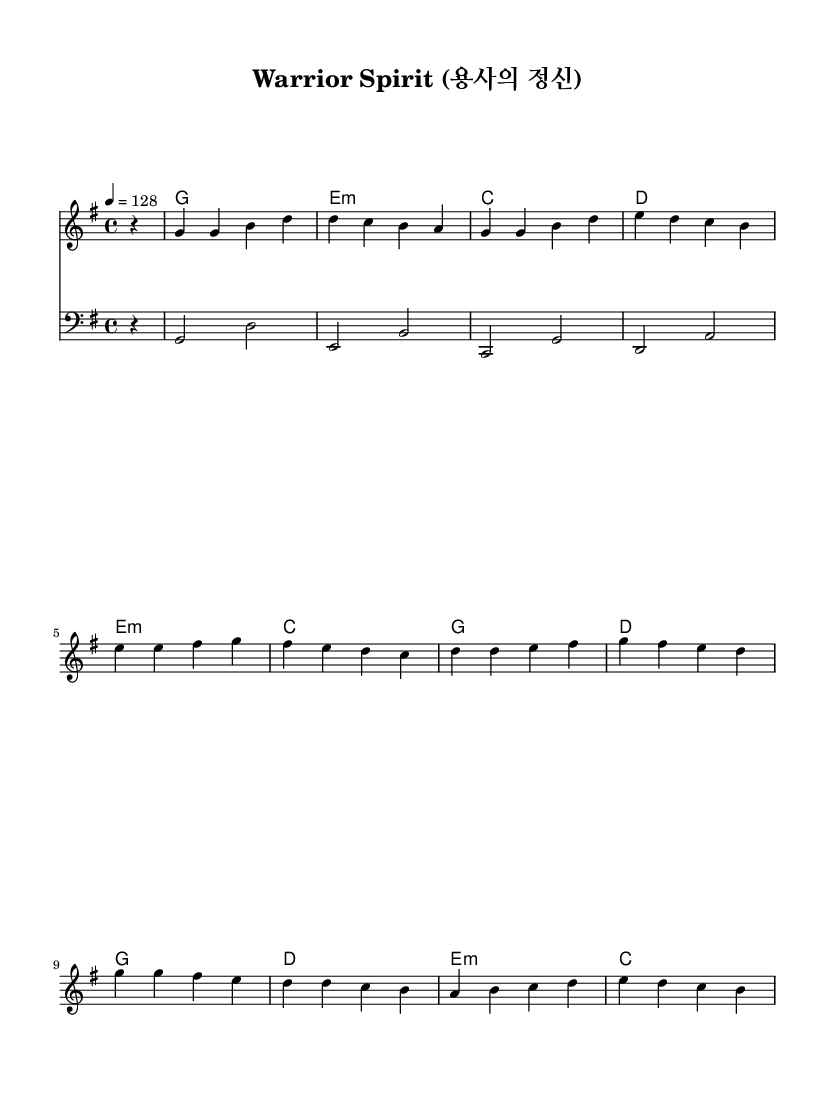What is the key signature of this music? The key signature is G major, which has one sharp (F#). The presence of the F# indicates the key of G major, as seen at the beginning of the sheet music.
Answer: G major What is the time signature of this music? The time signature is 4/4, as indicated at the start of the score. This means there are four beats in each measure, and the quarter note gets one beat.
Answer: 4/4 What is the tempo marking of this piece? The tempo marking is 128 beats per minute, indicated by the term "4 = 128" in the sheet, which specifies the speed of the music.
Answer: 128 How many sections are there in the piece? The piece has three distinct sections: the verse, pre-chorus, and chorus, indicated by the arrangement of the melody and harmonies.
Answer: Three What chord follows the bass line "e, b'" in the harmony? The chord that follows "e, b'" is E minor, as noted in the chord progression displayed in the harmony section.
Answer: E minor What are the characteristics of the K-Pop genre showcased in this piece? The piece showcases common K-Pop characteristics, including strong melodies, catchy choruses, and a clear structure with distinct sections, reflecting the genre's traits of emotional and patriotic themes.
Answer: Strong melodies 